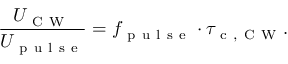<formula> <loc_0><loc_0><loc_500><loc_500>\frac { U _ { C W } } { U _ { p u l s e } } = f _ { p u l s e } \cdot \tau _ { c , C W } .</formula> 